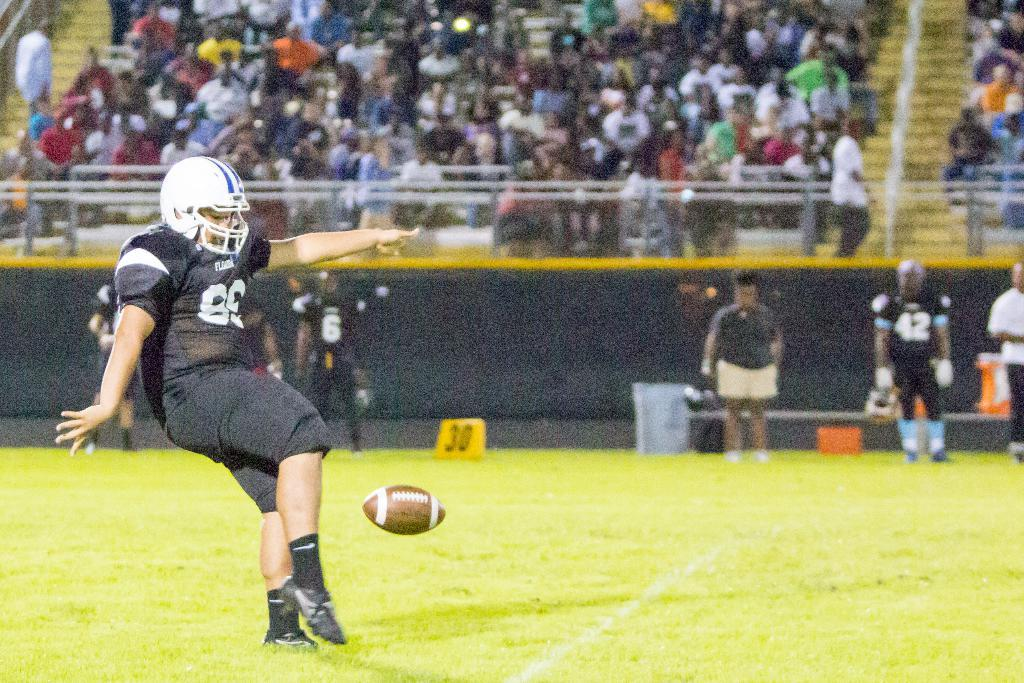What sport are the persons playing in the image? The persons are playing Rugby in the image. What object is central to the game being played? There is a ball in the image. Can you describe the people who are not actively participating in the game? There are spectators visible at the top of the image. What type of transport is being used by the players during the game? There is no transport visible in the image; the players are playing Rugby on a field. What kind of waste is being generated by the players during the game? There is no waste generation mentioned or visible in the image; the focus is on the game of Rugby being played. 